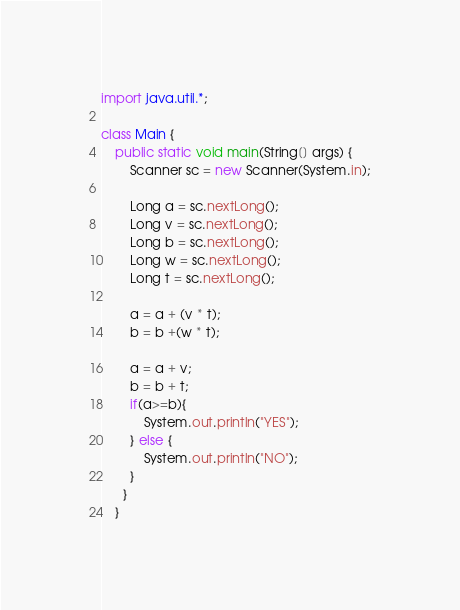<code> <loc_0><loc_0><loc_500><loc_500><_Java_>import java.util.*; 

class Main {
	public static void main(String[] args) {
		Scanner sc = new Scanner(System.in);

		Long a = sc.nextLong();
		Long v = sc.nextLong();
		Long b = sc.nextLong();
		Long w = sc.nextLong();
		Long t = sc.nextLong();
		
		a = a + (v * t);
		b = b +(w * t);

		a = a + v;
		b = b + t;
		if(a>=b){
			System.out.println("YES");
		} else {
			System.out.println("NO");
		}
	  }
	}		  </code> 